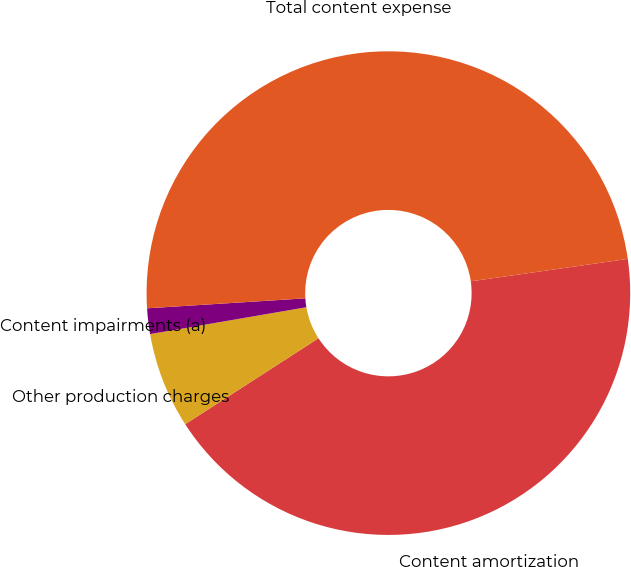Convert chart. <chart><loc_0><loc_0><loc_500><loc_500><pie_chart><fcel>Content amortization<fcel>Other production charges<fcel>Content impairments (a)<fcel>Total content expense<nl><fcel>43.14%<fcel>6.41%<fcel>1.71%<fcel>48.74%<nl></chart> 